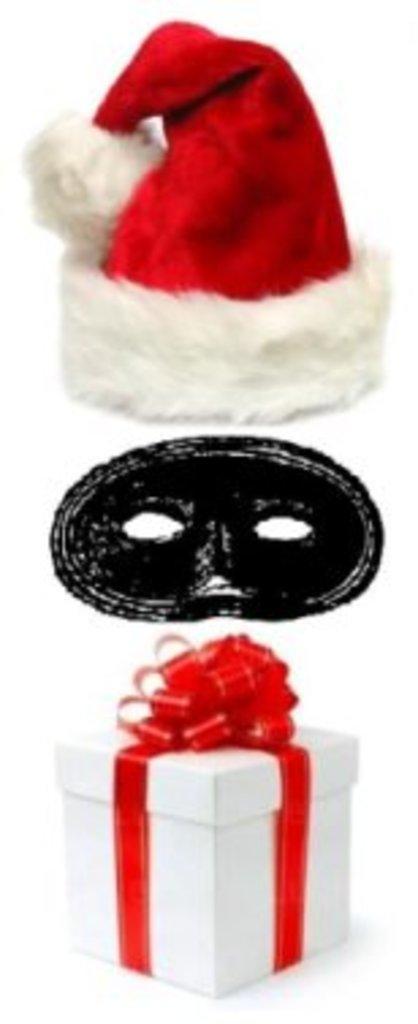Describe this image in one or two sentences. In this picture there is a cap, a mask and a gift box. The picture has white background and surface. 